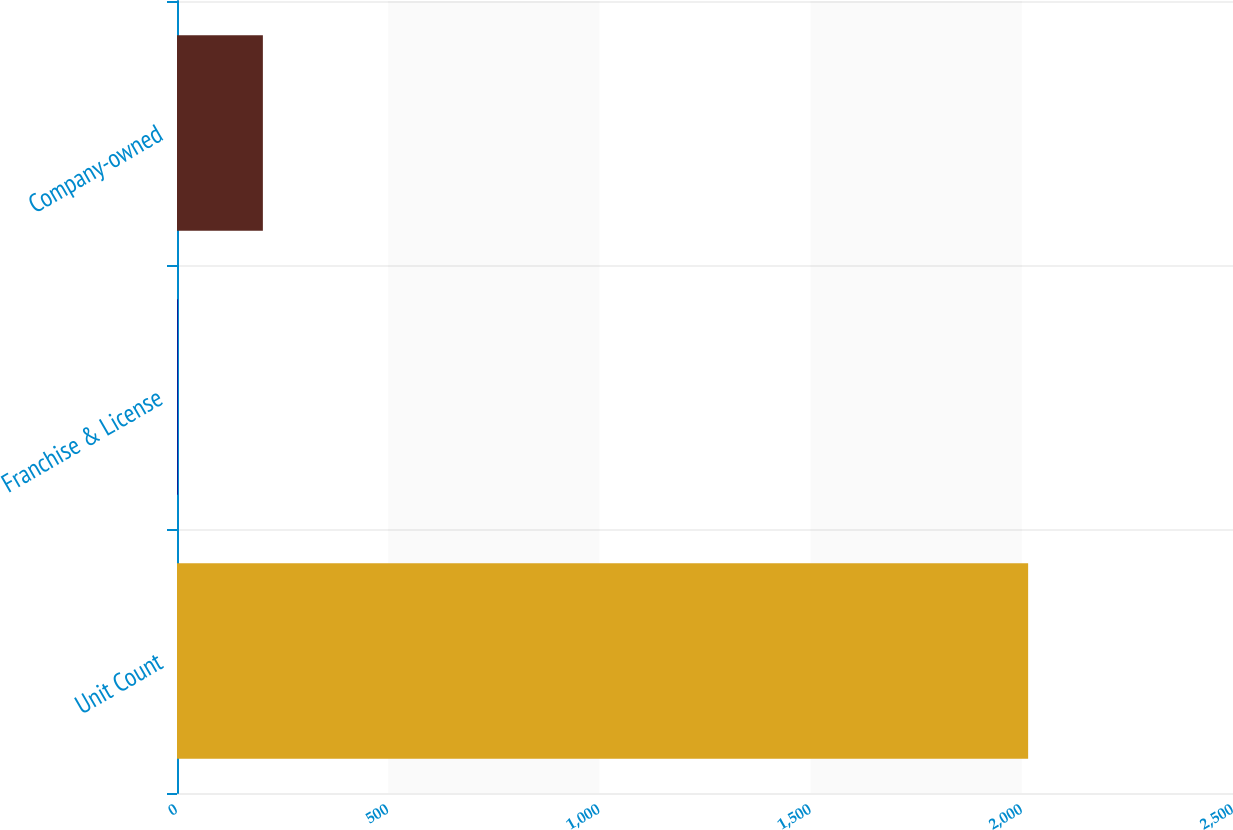Convert chart. <chart><loc_0><loc_0><loc_500><loc_500><bar_chart><fcel>Unit Count<fcel>Franchise & License<fcel>Company-owned<nl><fcel>2015<fcel>2<fcel>203.3<nl></chart> 